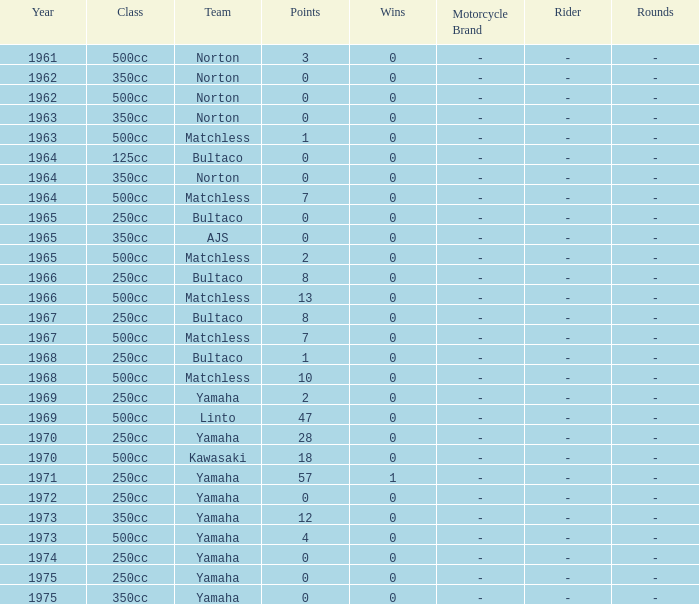Which class corresponds to more than 2 points, wins greater than 0, and a year earlier than 1973? 250cc. 